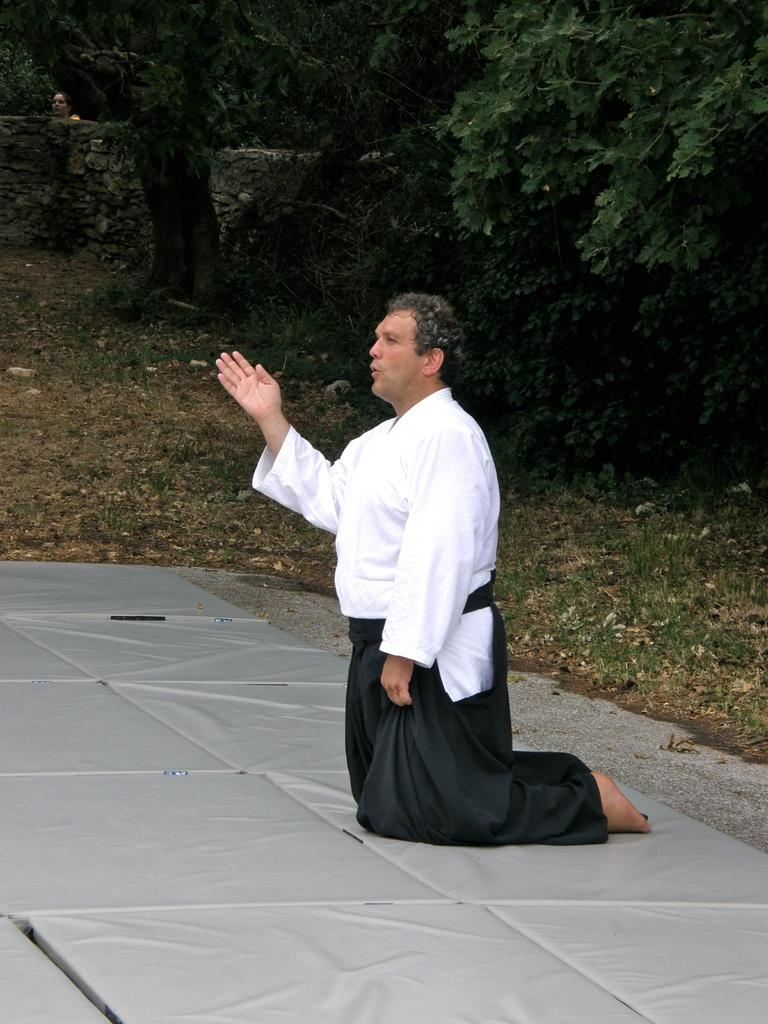Who is the main subject in the image? There is a man in the center of the image. What can be seen in the background of the image? There is greenery in the background of the image. Can you describe the other person in the image? There is another person behind a wall in the image. What type of pain is the man experiencing in the image? There is no indication in the image that the man is experiencing any pain. 